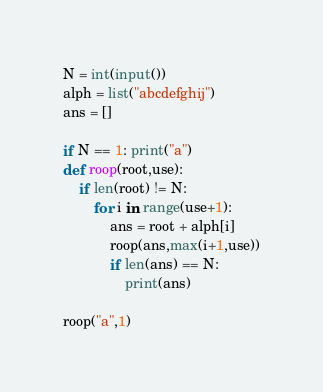Convert code to text. <code><loc_0><loc_0><loc_500><loc_500><_Python_>N = int(input())
alph = list("abcdefghij")
ans = []

if N == 1: print("a")
def roop(root,use):
    if len(root) != N:
        for i in range(use+1):
            ans = root + alph[i]
            roop(ans,max(i+1,use))
            if len(ans) == N:
                print(ans)

roop("a",1)</code> 